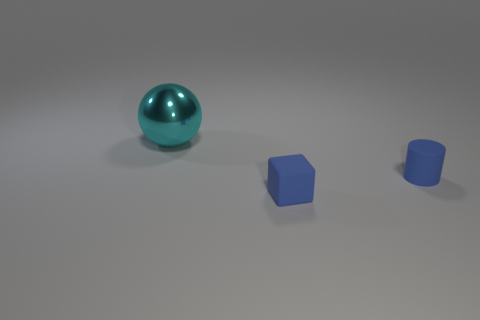Add 3 tiny things. How many objects exist? 6 Subtract all cubes. How many objects are left? 2 Subtract 0 red balls. How many objects are left? 3 Subtract all metallic things. Subtract all large cyan metal spheres. How many objects are left? 1 Add 3 blue blocks. How many blue blocks are left? 4 Add 1 large rubber cubes. How many large rubber cubes exist? 1 